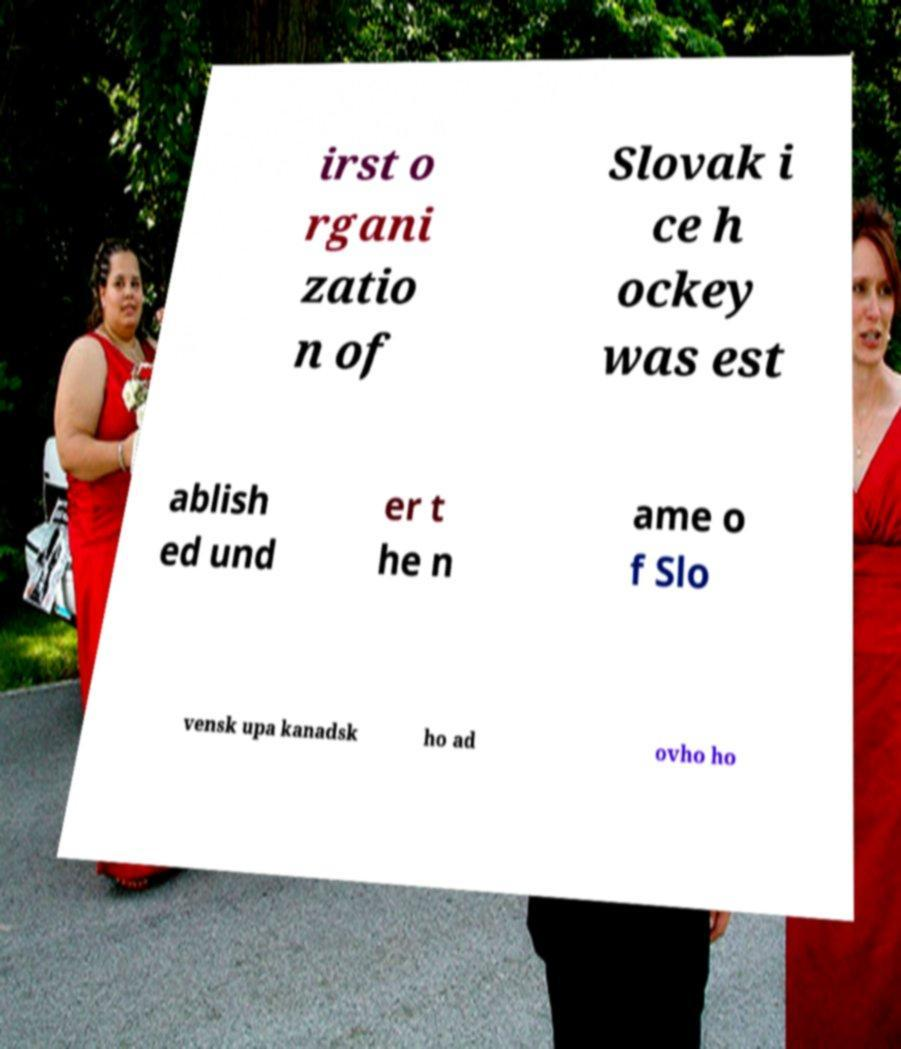Please identify and transcribe the text found in this image. irst o rgani zatio n of Slovak i ce h ockey was est ablish ed und er t he n ame o f Slo vensk upa kanadsk ho ad ovho ho 